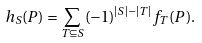<formula> <loc_0><loc_0><loc_500><loc_500>h _ { S } ( P ) = \sum _ { T \subseteq S } ( - 1 ) ^ { | S | - | T | } f _ { T } ( P ) .</formula> 